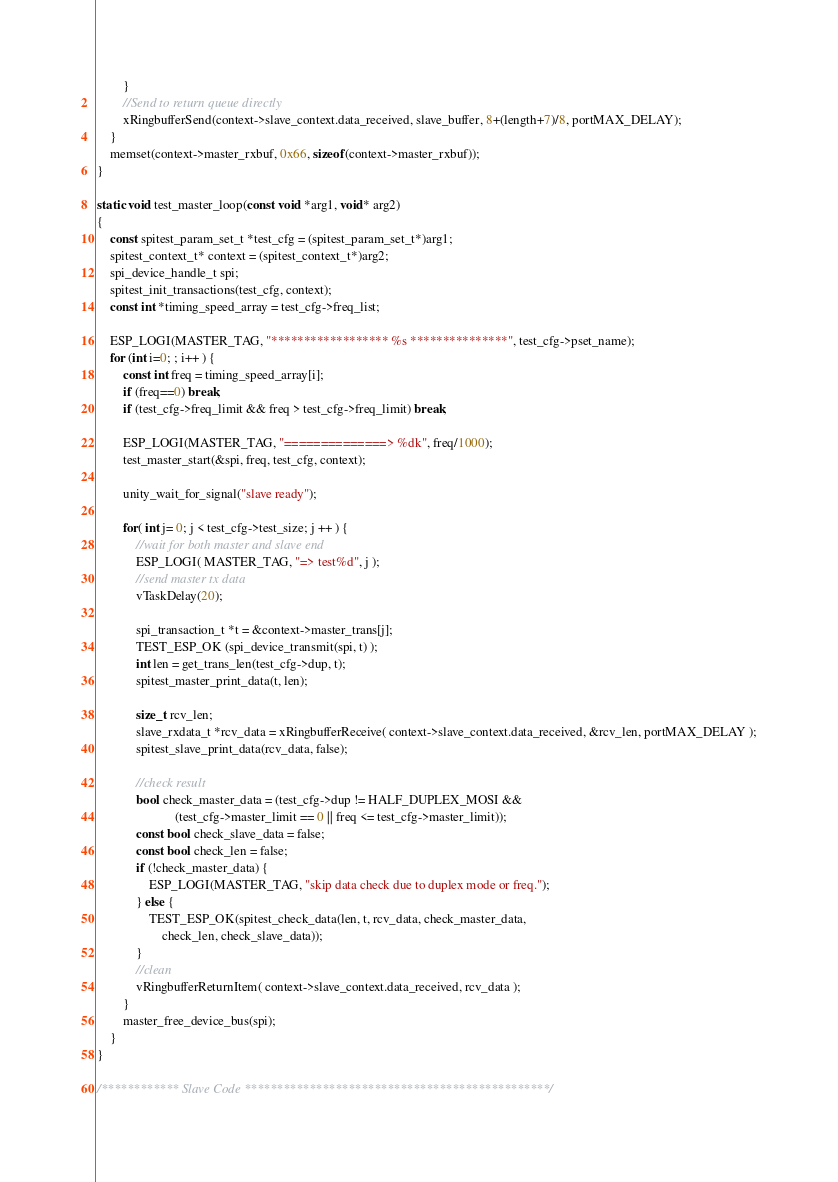Convert code to text. <code><loc_0><loc_0><loc_500><loc_500><_C_>        }
        //Send to return queue directly
        xRingbufferSend(context->slave_context.data_received, slave_buffer, 8+(length+7)/8, portMAX_DELAY);
    }
    memset(context->master_rxbuf, 0x66, sizeof(context->master_rxbuf));
}

static void test_master_loop(const void *arg1, void* arg2)
{
    const spitest_param_set_t *test_cfg = (spitest_param_set_t*)arg1;
    spitest_context_t* context = (spitest_context_t*)arg2;
    spi_device_handle_t spi;
    spitest_init_transactions(test_cfg, context);
    const int *timing_speed_array = test_cfg->freq_list;

    ESP_LOGI(MASTER_TAG, "****************** %s ***************", test_cfg->pset_name);
    for (int i=0; ; i++ ) {
        const int freq = timing_speed_array[i];
        if (freq==0) break;
        if (test_cfg->freq_limit && freq > test_cfg->freq_limit) break;

        ESP_LOGI(MASTER_TAG, "==============> %dk", freq/1000);
        test_master_start(&spi, freq, test_cfg, context);

        unity_wait_for_signal("slave ready");

        for( int j= 0; j < test_cfg->test_size; j ++ ) {
            //wait for both master and slave end
            ESP_LOGI( MASTER_TAG, "=> test%d", j );
            //send master tx data
            vTaskDelay(20);

            spi_transaction_t *t = &context->master_trans[j];
            TEST_ESP_OK (spi_device_transmit(spi, t) );
            int len = get_trans_len(test_cfg->dup, t);
            spitest_master_print_data(t, len);

            size_t rcv_len;
            slave_rxdata_t *rcv_data = xRingbufferReceive( context->slave_context.data_received, &rcv_len, portMAX_DELAY );
            spitest_slave_print_data(rcv_data, false);

            //check result
            bool check_master_data = (test_cfg->dup != HALF_DUPLEX_MOSI &&
                        (test_cfg->master_limit == 0 || freq <= test_cfg->master_limit));
            const bool check_slave_data = false;
            const bool check_len = false;
            if (!check_master_data) {
                ESP_LOGI(MASTER_TAG, "skip data check due to duplex mode or freq.");
            } else {
                TEST_ESP_OK(spitest_check_data(len, t, rcv_data, check_master_data,
                    check_len, check_slave_data));
            }
            //clean
            vRingbufferReturnItem( context->slave_context.data_received, rcv_data );
        }
        master_free_device_bus(spi);
    }
}

/************ Slave Code ***********************************************/</code> 